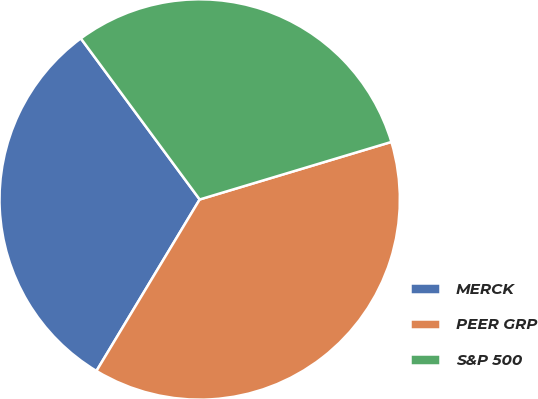Convert chart to OTSL. <chart><loc_0><loc_0><loc_500><loc_500><pie_chart><fcel>MERCK<fcel>PEER GRP<fcel>S&P 500<nl><fcel>31.26%<fcel>38.27%<fcel>30.48%<nl></chart> 